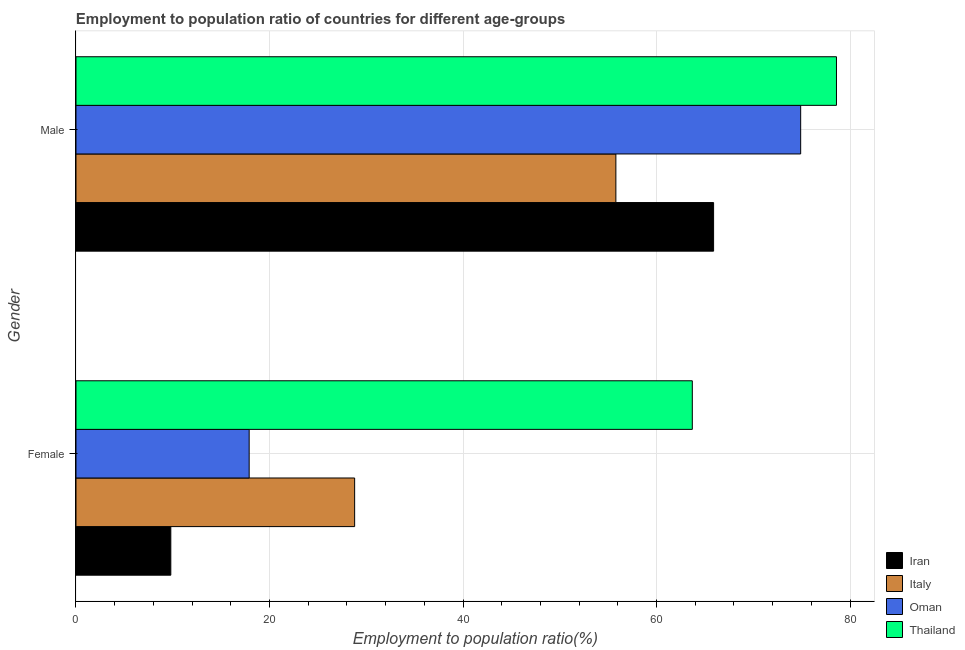How many groups of bars are there?
Your response must be concise. 2. Are the number of bars per tick equal to the number of legend labels?
Provide a short and direct response. Yes. How many bars are there on the 2nd tick from the top?
Ensure brevity in your answer.  4. What is the label of the 2nd group of bars from the top?
Your answer should be very brief. Female. What is the employment to population ratio(female) in Italy?
Keep it short and to the point. 28.8. Across all countries, what is the maximum employment to population ratio(male)?
Provide a succinct answer. 78.6. Across all countries, what is the minimum employment to population ratio(female)?
Make the answer very short. 9.8. In which country was the employment to population ratio(male) maximum?
Give a very brief answer. Thailand. In which country was the employment to population ratio(female) minimum?
Provide a succinct answer. Iran. What is the total employment to population ratio(female) in the graph?
Provide a succinct answer. 120.2. What is the difference between the employment to population ratio(male) in Italy and that in Thailand?
Give a very brief answer. -22.8. What is the difference between the employment to population ratio(female) in Thailand and the employment to population ratio(male) in Iran?
Provide a succinct answer. -2.2. What is the average employment to population ratio(male) per country?
Give a very brief answer. 68.8. What is the difference between the employment to population ratio(female) and employment to population ratio(male) in Italy?
Ensure brevity in your answer.  -27. In how many countries, is the employment to population ratio(female) greater than 8 %?
Provide a succinct answer. 4. What is the ratio of the employment to population ratio(female) in Thailand to that in Italy?
Your answer should be compact. 2.21. What does the 4th bar from the top in Female represents?
Keep it short and to the point. Iran. What is the difference between two consecutive major ticks on the X-axis?
Offer a terse response. 20. Are the values on the major ticks of X-axis written in scientific E-notation?
Make the answer very short. No. Does the graph contain any zero values?
Give a very brief answer. No. Where does the legend appear in the graph?
Offer a terse response. Bottom right. How many legend labels are there?
Keep it short and to the point. 4. What is the title of the graph?
Your answer should be compact. Employment to population ratio of countries for different age-groups. What is the label or title of the X-axis?
Keep it short and to the point. Employment to population ratio(%). What is the Employment to population ratio(%) in Iran in Female?
Offer a very short reply. 9.8. What is the Employment to population ratio(%) in Italy in Female?
Make the answer very short. 28.8. What is the Employment to population ratio(%) in Oman in Female?
Offer a very short reply. 17.9. What is the Employment to population ratio(%) of Thailand in Female?
Keep it short and to the point. 63.7. What is the Employment to population ratio(%) of Iran in Male?
Make the answer very short. 65.9. What is the Employment to population ratio(%) of Italy in Male?
Offer a terse response. 55.8. What is the Employment to population ratio(%) in Oman in Male?
Make the answer very short. 74.9. What is the Employment to population ratio(%) of Thailand in Male?
Make the answer very short. 78.6. Across all Gender, what is the maximum Employment to population ratio(%) in Iran?
Your answer should be compact. 65.9. Across all Gender, what is the maximum Employment to population ratio(%) of Italy?
Keep it short and to the point. 55.8. Across all Gender, what is the maximum Employment to population ratio(%) of Oman?
Offer a terse response. 74.9. Across all Gender, what is the maximum Employment to population ratio(%) of Thailand?
Provide a succinct answer. 78.6. Across all Gender, what is the minimum Employment to population ratio(%) of Iran?
Provide a succinct answer. 9.8. Across all Gender, what is the minimum Employment to population ratio(%) of Italy?
Offer a very short reply. 28.8. Across all Gender, what is the minimum Employment to population ratio(%) of Oman?
Offer a terse response. 17.9. Across all Gender, what is the minimum Employment to population ratio(%) of Thailand?
Provide a succinct answer. 63.7. What is the total Employment to population ratio(%) in Iran in the graph?
Provide a short and direct response. 75.7. What is the total Employment to population ratio(%) in Italy in the graph?
Your response must be concise. 84.6. What is the total Employment to population ratio(%) of Oman in the graph?
Keep it short and to the point. 92.8. What is the total Employment to population ratio(%) in Thailand in the graph?
Give a very brief answer. 142.3. What is the difference between the Employment to population ratio(%) in Iran in Female and that in Male?
Offer a terse response. -56.1. What is the difference between the Employment to population ratio(%) in Italy in Female and that in Male?
Make the answer very short. -27. What is the difference between the Employment to population ratio(%) of Oman in Female and that in Male?
Provide a short and direct response. -57. What is the difference between the Employment to population ratio(%) in Thailand in Female and that in Male?
Provide a short and direct response. -14.9. What is the difference between the Employment to population ratio(%) in Iran in Female and the Employment to population ratio(%) in Italy in Male?
Your response must be concise. -46. What is the difference between the Employment to population ratio(%) in Iran in Female and the Employment to population ratio(%) in Oman in Male?
Give a very brief answer. -65.1. What is the difference between the Employment to population ratio(%) of Iran in Female and the Employment to population ratio(%) of Thailand in Male?
Give a very brief answer. -68.8. What is the difference between the Employment to population ratio(%) in Italy in Female and the Employment to population ratio(%) in Oman in Male?
Offer a terse response. -46.1. What is the difference between the Employment to population ratio(%) in Italy in Female and the Employment to population ratio(%) in Thailand in Male?
Your response must be concise. -49.8. What is the difference between the Employment to population ratio(%) of Oman in Female and the Employment to population ratio(%) of Thailand in Male?
Provide a short and direct response. -60.7. What is the average Employment to population ratio(%) of Iran per Gender?
Provide a short and direct response. 37.85. What is the average Employment to population ratio(%) in Italy per Gender?
Offer a terse response. 42.3. What is the average Employment to population ratio(%) in Oman per Gender?
Make the answer very short. 46.4. What is the average Employment to population ratio(%) in Thailand per Gender?
Offer a terse response. 71.15. What is the difference between the Employment to population ratio(%) of Iran and Employment to population ratio(%) of Italy in Female?
Keep it short and to the point. -19. What is the difference between the Employment to population ratio(%) in Iran and Employment to population ratio(%) in Oman in Female?
Offer a very short reply. -8.1. What is the difference between the Employment to population ratio(%) of Iran and Employment to population ratio(%) of Thailand in Female?
Give a very brief answer. -53.9. What is the difference between the Employment to population ratio(%) in Italy and Employment to population ratio(%) in Oman in Female?
Offer a very short reply. 10.9. What is the difference between the Employment to population ratio(%) in Italy and Employment to population ratio(%) in Thailand in Female?
Your answer should be very brief. -34.9. What is the difference between the Employment to population ratio(%) of Oman and Employment to population ratio(%) of Thailand in Female?
Your answer should be very brief. -45.8. What is the difference between the Employment to population ratio(%) of Iran and Employment to population ratio(%) of Italy in Male?
Offer a terse response. 10.1. What is the difference between the Employment to population ratio(%) of Iran and Employment to population ratio(%) of Thailand in Male?
Your answer should be compact. -12.7. What is the difference between the Employment to population ratio(%) in Italy and Employment to population ratio(%) in Oman in Male?
Your response must be concise. -19.1. What is the difference between the Employment to population ratio(%) in Italy and Employment to population ratio(%) in Thailand in Male?
Your answer should be very brief. -22.8. What is the ratio of the Employment to population ratio(%) of Iran in Female to that in Male?
Provide a short and direct response. 0.15. What is the ratio of the Employment to population ratio(%) of Italy in Female to that in Male?
Provide a short and direct response. 0.52. What is the ratio of the Employment to population ratio(%) in Oman in Female to that in Male?
Make the answer very short. 0.24. What is the ratio of the Employment to population ratio(%) of Thailand in Female to that in Male?
Offer a terse response. 0.81. What is the difference between the highest and the second highest Employment to population ratio(%) of Iran?
Your answer should be very brief. 56.1. What is the difference between the highest and the second highest Employment to population ratio(%) in Oman?
Keep it short and to the point. 57. What is the difference between the highest and the lowest Employment to population ratio(%) of Iran?
Your answer should be very brief. 56.1. What is the difference between the highest and the lowest Employment to population ratio(%) of Oman?
Provide a succinct answer. 57. What is the difference between the highest and the lowest Employment to population ratio(%) of Thailand?
Your response must be concise. 14.9. 